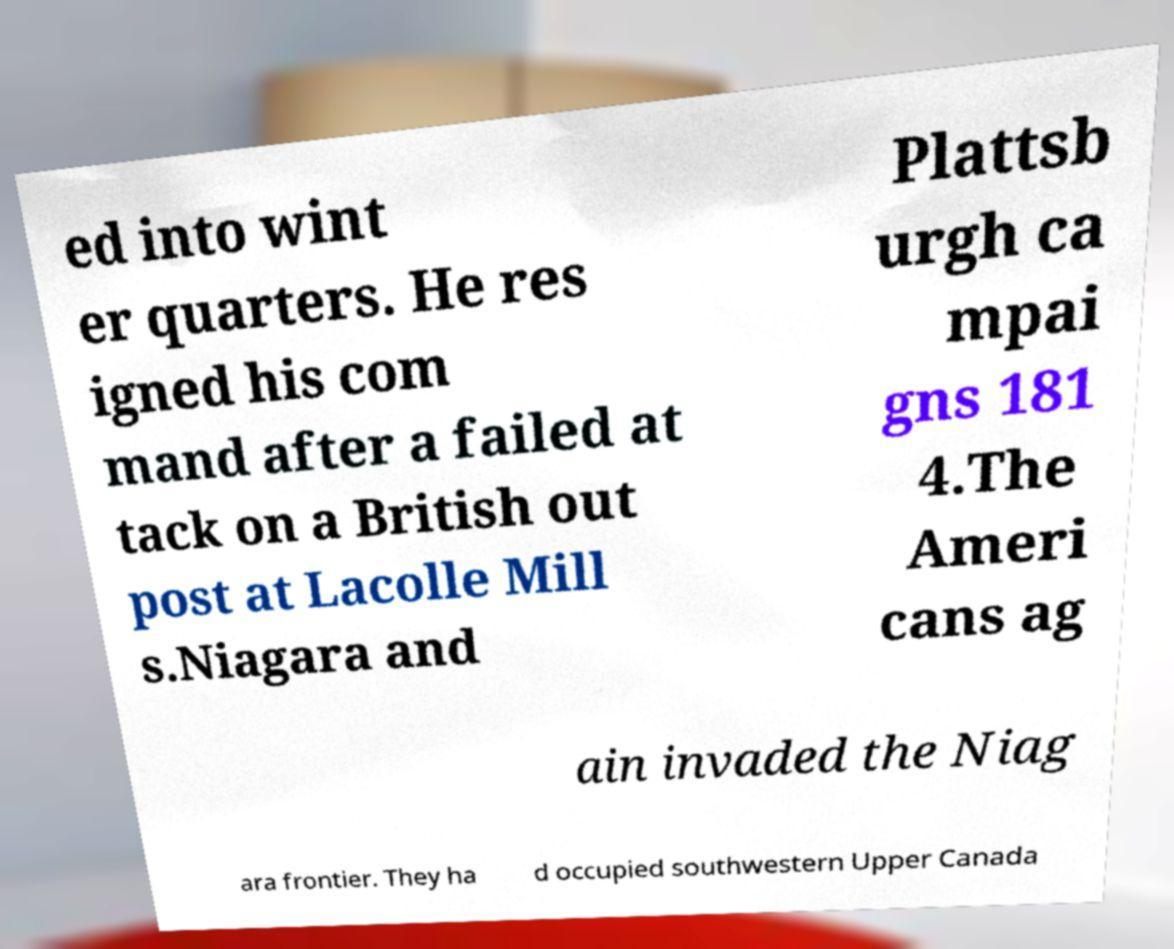Please identify and transcribe the text found in this image. ed into wint er quarters. He res igned his com mand after a failed at tack on a British out post at Lacolle Mill s.Niagara and Plattsb urgh ca mpai gns 181 4.The Ameri cans ag ain invaded the Niag ara frontier. They ha d occupied southwestern Upper Canada 